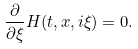Convert formula to latex. <formula><loc_0><loc_0><loc_500><loc_500>\frac { \partial } { \partial \xi } H ( t , x , i \xi ) = 0 .</formula> 